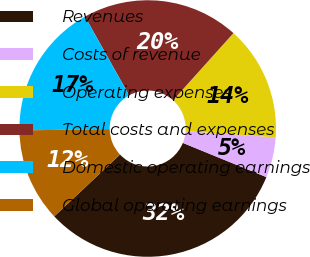Convert chart. <chart><loc_0><loc_0><loc_500><loc_500><pie_chart><fcel>Revenues<fcel>Costs of revenue<fcel>Operating expenses<fcel>Total costs and expenses<fcel>Domestic operating earnings<fcel>Global operating earnings<nl><fcel>31.81%<fcel>5.09%<fcel>14.44%<fcel>19.78%<fcel>17.11%<fcel>11.77%<nl></chart> 